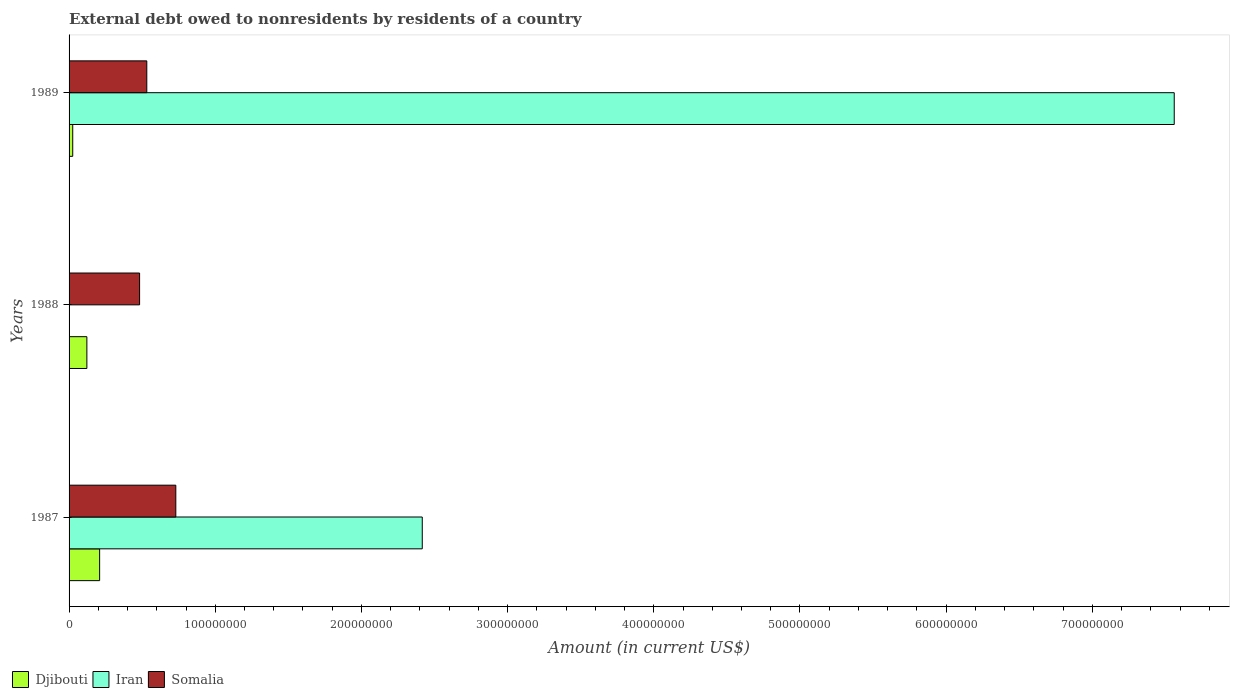How many groups of bars are there?
Offer a very short reply. 3. What is the external debt owed by residents in Iran in 1987?
Your answer should be compact. 2.42e+08. Across all years, what is the maximum external debt owed by residents in Djibouti?
Provide a short and direct response. 2.09e+07. In which year was the external debt owed by residents in Djibouti maximum?
Give a very brief answer. 1987. What is the total external debt owed by residents in Djibouti in the graph?
Your response must be concise. 3.56e+07. What is the difference between the external debt owed by residents in Djibouti in 1987 and that in 1988?
Provide a short and direct response. 8.72e+06. What is the difference between the external debt owed by residents in Somalia in 1988 and the external debt owed by residents in Djibouti in 1989?
Provide a succinct answer. 4.57e+07. What is the average external debt owed by residents in Iran per year?
Give a very brief answer. 3.33e+08. In the year 1987, what is the difference between the external debt owed by residents in Iran and external debt owed by residents in Djibouti?
Provide a short and direct response. 2.21e+08. What is the ratio of the external debt owed by residents in Djibouti in 1987 to that in 1988?
Offer a very short reply. 1.72. Is the external debt owed by residents in Somalia in 1987 less than that in 1989?
Provide a short and direct response. No. What is the difference between the highest and the second highest external debt owed by residents in Djibouti?
Your response must be concise. 8.72e+06. What is the difference between the highest and the lowest external debt owed by residents in Iran?
Make the answer very short. 7.56e+08. Is the sum of the external debt owed by residents in Djibouti in 1987 and 1988 greater than the maximum external debt owed by residents in Somalia across all years?
Provide a short and direct response. No. Are all the bars in the graph horizontal?
Give a very brief answer. Yes. What is the difference between two consecutive major ticks on the X-axis?
Provide a succinct answer. 1.00e+08. How many legend labels are there?
Ensure brevity in your answer.  3. How are the legend labels stacked?
Your response must be concise. Horizontal. What is the title of the graph?
Provide a short and direct response. External debt owed to nonresidents by residents of a country. Does "Angola" appear as one of the legend labels in the graph?
Make the answer very short. No. What is the label or title of the Y-axis?
Give a very brief answer. Years. What is the Amount (in current US$) in Djibouti in 1987?
Your answer should be very brief. 2.09e+07. What is the Amount (in current US$) in Iran in 1987?
Make the answer very short. 2.42e+08. What is the Amount (in current US$) in Somalia in 1987?
Make the answer very short. 7.30e+07. What is the Amount (in current US$) of Djibouti in 1988?
Provide a succinct answer. 1.22e+07. What is the Amount (in current US$) of Iran in 1988?
Provide a succinct answer. 0. What is the Amount (in current US$) of Somalia in 1988?
Provide a short and direct response. 4.82e+07. What is the Amount (in current US$) of Djibouti in 1989?
Your answer should be very brief. 2.51e+06. What is the Amount (in current US$) in Iran in 1989?
Give a very brief answer. 7.56e+08. What is the Amount (in current US$) of Somalia in 1989?
Your answer should be very brief. 5.32e+07. Across all years, what is the maximum Amount (in current US$) of Djibouti?
Your answer should be compact. 2.09e+07. Across all years, what is the maximum Amount (in current US$) in Iran?
Ensure brevity in your answer.  7.56e+08. Across all years, what is the maximum Amount (in current US$) of Somalia?
Provide a succinct answer. 7.30e+07. Across all years, what is the minimum Amount (in current US$) in Djibouti?
Your response must be concise. 2.51e+06. Across all years, what is the minimum Amount (in current US$) in Somalia?
Your answer should be very brief. 4.82e+07. What is the total Amount (in current US$) in Djibouti in the graph?
Make the answer very short. 3.56e+07. What is the total Amount (in current US$) of Iran in the graph?
Keep it short and to the point. 9.98e+08. What is the total Amount (in current US$) of Somalia in the graph?
Ensure brevity in your answer.  1.74e+08. What is the difference between the Amount (in current US$) of Djibouti in 1987 and that in 1988?
Provide a short and direct response. 8.72e+06. What is the difference between the Amount (in current US$) of Somalia in 1987 and that in 1988?
Provide a succinct answer. 2.48e+07. What is the difference between the Amount (in current US$) of Djibouti in 1987 and that in 1989?
Provide a succinct answer. 1.84e+07. What is the difference between the Amount (in current US$) in Iran in 1987 and that in 1989?
Your answer should be compact. -5.14e+08. What is the difference between the Amount (in current US$) in Somalia in 1987 and that in 1989?
Your answer should be very brief. 1.99e+07. What is the difference between the Amount (in current US$) of Djibouti in 1988 and that in 1989?
Make the answer very short. 9.67e+06. What is the difference between the Amount (in current US$) of Somalia in 1988 and that in 1989?
Offer a very short reply. -4.92e+06. What is the difference between the Amount (in current US$) in Djibouti in 1987 and the Amount (in current US$) in Somalia in 1988?
Provide a short and direct response. -2.73e+07. What is the difference between the Amount (in current US$) of Iran in 1987 and the Amount (in current US$) of Somalia in 1988?
Your answer should be compact. 1.93e+08. What is the difference between the Amount (in current US$) of Djibouti in 1987 and the Amount (in current US$) of Iran in 1989?
Your response must be concise. -7.35e+08. What is the difference between the Amount (in current US$) in Djibouti in 1987 and the Amount (in current US$) in Somalia in 1989?
Make the answer very short. -3.23e+07. What is the difference between the Amount (in current US$) of Iran in 1987 and the Amount (in current US$) of Somalia in 1989?
Offer a terse response. 1.88e+08. What is the difference between the Amount (in current US$) in Djibouti in 1988 and the Amount (in current US$) in Iran in 1989?
Offer a very short reply. -7.44e+08. What is the difference between the Amount (in current US$) in Djibouti in 1988 and the Amount (in current US$) in Somalia in 1989?
Offer a very short reply. -4.10e+07. What is the average Amount (in current US$) of Djibouti per year?
Give a very brief answer. 1.19e+07. What is the average Amount (in current US$) of Iran per year?
Your answer should be compact. 3.33e+08. What is the average Amount (in current US$) of Somalia per year?
Provide a succinct answer. 5.81e+07. In the year 1987, what is the difference between the Amount (in current US$) in Djibouti and Amount (in current US$) in Iran?
Give a very brief answer. -2.21e+08. In the year 1987, what is the difference between the Amount (in current US$) in Djibouti and Amount (in current US$) in Somalia?
Your response must be concise. -5.21e+07. In the year 1987, what is the difference between the Amount (in current US$) in Iran and Amount (in current US$) in Somalia?
Provide a short and direct response. 1.69e+08. In the year 1988, what is the difference between the Amount (in current US$) in Djibouti and Amount (in current US$) in Somalia?
Provide a short and direct response. -3.61e+07. In the year 1989, what is the difference between the Amount (in current US$) in Djibouti and Amount (in current US$) in Iran?
Offer a terse response. -7.54e+08. In the year 1989, what is the difference between the Amount (in current US$) in Djibouti and Amount (in current US$) in Somalia?
Your answer should be compact. -5.07e+07. In the year 1989, what is the difference between the Amount (in current US$) in Iran and Amount (in current US$) in Somalia?
Ensure brevity in your answer.  7.03e+08. What is the ratio of the Amount (in current US$) in Djibouti in 1987 to that in 1988?
Provide a short and direct response. 1.72. What is the ratio of the Amount (in current US$) of Somalia in 1987 to that in 1988?
Keep it short and to the point. 1.51. What is the ratio of the Amount (in current US$) of Djibouti in 1987 to that in 1989?
Offer a terse response. 8.34. What is the ratio of the Amount (in current US$) of Iran in 1987 to that in 1989?
Offer a very short reply. 0.32. What is the ratio of the Amount (in current US$) of Somalia in 1987 to that in 1989?
Your answer should be very brief. 1.37. What is the ratio of the Amount (in current US$) in Djibouti in 1988 to that in 1989?
Provide a short and direct response. 4.86. What is the ratio of the Amount (in current US$) of Somalia in 1988 to that in 1989?
Make the answer very short. 0.91. What is the difference between the highest and the second highest Amount (in current US$) in Djibouti?
Offer a very short reply. 8.72e+06. What is the difference between the highest and the second highest Amount (in current US$) in Somalia?
Offer a very short reply. 1.99e+07. What is the difference between the highest and the lowest Amount (in current US$) in Djibouti?
Provide a short and direct response. 1.84e+07. What is the difference between the highest and the lowest Amount (in current US$) in Iran?
Offer a terse response. 7.56e+08. What is the difference between the highest and the lowest Amount (in current US$) in Somalia?
Your answer should be compact. 2.48e+07. 